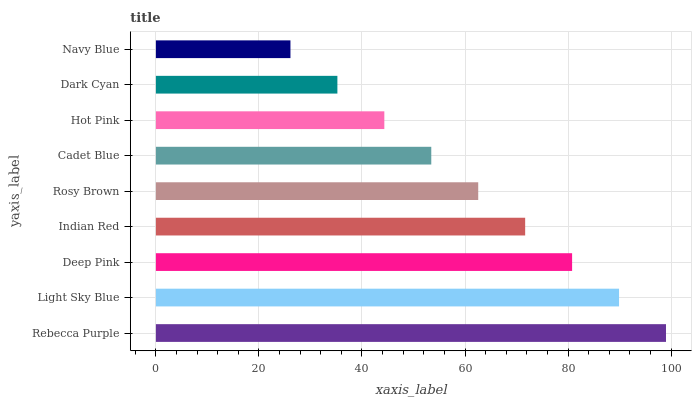Is Navy Blue the minimum?
Answer yes or no. Yes. Is Rebecca Purple the maximum?
Answer yes or no. Yes. Is Light Sky Blue the minimum?
Answer yes or no. No. Is Light Sky Blue the maximum?
Answer yes or no. No. Is Rebecca Purple greater than Light Sky Blue?
Answer yes or no. Yes. Is Light Sky Blue less than Rebecca Purple?
Answer yes or no. Yes. Is Light Sky Blue greater than Rebecca Purple?
Answer yes or no. No. Is Rebecca Purple less than Light Sky Blue?
Answer yes or no. No. Is Rosy Brown the high median?
Answer yes or no. Yes. Is Rosy Brown the low median?
Answer yes or no. Yes. Is Light Sky Blue the high median?
Answer yes or no. No. Is Indian Red the low median?
Answer yes or no. No. 